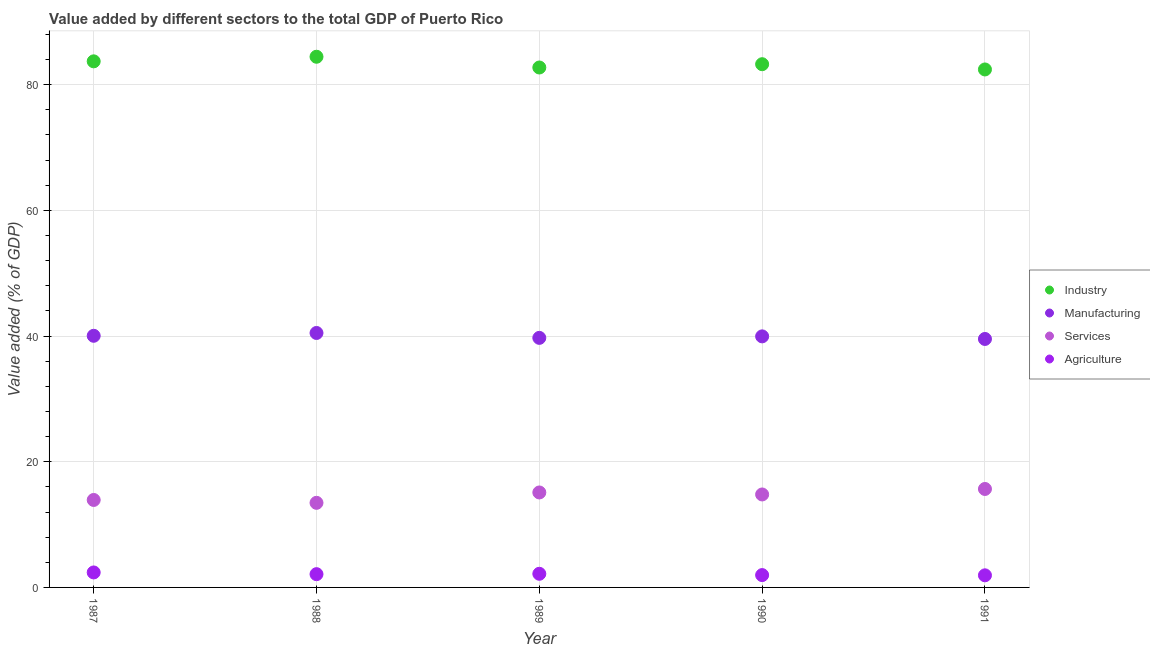Is the number of dotlines equal to the number of legend labels?
Ensure brevity in your answer.  Yes. What is the value added by manufacturing sector in 1989?
Your answer should be very brief. 39.7. Across all years, what is the maximum value added by agricultural sector?
Keep it short and to the point. 2.38. Across all years, what is the minimum value added by agricultural sector?
Your response must be concise. 1.93. In which year was the value added by services sector maximum?
Your answer should be very brief. 1991. In which year was the value added by industrial sector minimum?
Your answer should be very brief. 1991. What is the total value added by manufacturing sector in the graph?
Make the answer very short. 199.7. What is the difference between the value added by agricultural sector in 1988 and that in 1989?
Give a very brief answer. -0.06. What is the difference between the value added by industrial sector in 1987 and the value added by agricultural sector in 1988?
Offer a terse response. 81.59. What is the average value added by services sector per year?
Offer a terse response. 14.59. In the year 1990, what is the difference between the value added by industrial sector and value added by manufacturing sector?
Give a very brief answer. 43.3. In how many years, is the value added by services sector greater than 72 %?
Provide a succinct answer. 0. What is the ratio of the value added by services sector in 1987 to that in 1988?
Make the answer very short. 1.03. Is the difference between the value added by services sector in 1989 and 1991 greater than the difference between the value added by agricultural sector in 1989 and 1991?
Make the answer very short. No. What is the difference between the highest and the second highest value added by industrial sector?
Offer a terse response. 0.73. What is the difference between the highest and the lowest value added by agricultural sector?
Your answer should be very brief. 0.46. In how many years, is the value added by industrial sector greater than the average value added by industrial sector taken over all years?
Give a very brief answer. 2. Is it the case that in every year, the sum of the value added by services sector and value added by industrial sector is greater than the sum of value added by agricultural sector and value added by manufacturing sector?
Make the answer very short. Yes. Is it the case that in every year, the sum of the value added by industrial sector and value added by manufacturing sector is greater than the value added by services sector?
Keep it short and to the point. Yes. Is the value added by manufacturing sector strictly greater than the value added by industrial sector over the years?
Ensure brevity in your answer.  No. Does the graph contain any zero values?
Your response must be concise. No. Does the graph contain grids?
Offer a very short reply. Yes. Where does the legend appear in the graph?
Make the answer very short. Center right. How many legend labels are there?
Your answer should be very brief. 4. What is the title of the graph?
Provide a succinct answer. Value added by different sectors to the total GDP of Puerto Rico. What is the label or title of the X-axis?
Make the answer very short. Year. What is the label or title of the Y-axis?
Ensure brevity in your answer.  Value added (% of GDP). What is the Value added (% of GDP) of Industry in 1987?
Provide a succinct answer. 83.7. What is the Value added (% of GDP) of Manufacturing in 1987?
Offer a very short reply. 40.04. What is the Value added (% of GDP) in Services in 1987?
Give a very brief answer. 13.92. What is the Value added (% of GDP) of Agriculture in 1987?
Your answer should be compact. 2.38. What is the Value added (% of GDP) of Industry in 1988?
Make the answer very short. 84.43. What is the Value added (% of GDP) in Manufacturing in 1988?
Provide a short and direct response. 40.48. What is the Value added (% of GDP) in Services in 1988?
Offer a very short reply. 13.46. What is the Value added (% of GDP) of Agriculture in 1988?
Ensure brevity in your answer.  2.11. What is the Value added (% of GDP) in Industry in 1989?
Your answer should be compact. 82.72. What is the Value added (% of GDP) in Manufacturing in 1989?
Ensure brevity in your answer.  39.7. What is the Value added (% of GDP) of Services in 1989?
Provide a succinct answer. 15.11. What is the Value added (% of GDP) of Agriculture in 1989?
Offer a terse response. 2.17. What is the Value added (% of GDP) of Industry in 1990?
Provide a short and direct response. 83.25. What is the Value added (% of GDP) in Manufacturing in 1990?
Offer a very short reply. 39.94. What is the Value added (% of GDP) in Services in 1990?
Offer a terse response. 14.79. What is the Value added (% of GDP) of Agriculture in 1990?
Make the answer very short. 1.96. What is the Value added (% of GDP) in Industry in 1991?
Your answer should be very brief. 82.41. What is the Value added (% of GDP) of Manufacturing in 1991?
Give a very brief answer. 39.53. What is the Value added (% of GDP) of Services in 1991?
Ensure brevity in your answer.  15.66. What is the Value added (% of GDP) in Agriculture in 1991?
Give a very brief answer. 1.93. Across all years, what is the maximum Value added (% of GDP) in Industry?
Make the answer very short. 84.43. Across all years, what is the maximum Value added (% of GDP) in Manufacturing?
Your response must be concise. 40.48. Across all years, what is the maximum Value added (% of GDP) of Services?
Offer a very short reply. 15.66. Across all years, what is the maximum Value added (% of GDP) of Agriculture?
Offer a very short reply. 2.38. Across all years, what is the minimum Value added (% of GDP) in Industry?
Your response must be concise. 82.41. Across all years, what is the minimum Value added (% of GDP) of Manufacturing?
Offer a very short reply. 39.53. Across all years, what is the minimum Value added (% of GDP) in Services?
Your response must be concise. 13.46. Across all years, what is the minimum Value added (% of GDP) of Agriculture?
Your answer should be very brief. 1.93. What is the total Value added (% of GDP) of Industry in the graph?
Provide a succinct answer. 416.51. What is the total Value added (% of GDP) of Manufacturing in the graph?
Offer a terse response. 199.7. What is the total Value added (% of GDP) in Services in the graph?
Make the answer very short. 72.94. What is the total Value added (% of GDP) in Agriculture in the graph?
Your answer should be compact. 10.55. What is the difference between the Value added (% of GDP) in Industry in 1987 and that in 1988?
Your response must be concise. -0.73. What is the difference between the Value added (% of GDP) of Manufacturing in 1987 and that in 1988?
Your response must be concise. -0.45. What is the difference between the Value added (% of GDP) in Services in 1987 and that in 1988?
Make the answer very short. 0.46. What is the difference between the Value added (% of GDP) in Agriculture in 1987 and that in 1988?
Give a very brief answer. 0.27. What is the difference between the Value added (% of GDP) in Industry in 1987 and that in 1989?
Your answer should be compact. 0.98. What is the difference between the Value added (% of GDP) of Manufacturing in 1987 and that in 1989?
Your answer should be very brief. 0.33. What is the difference between the Value added (% of GDP) in Services in 1987 and that in 1989?
Offer a very short reply. -1.19. What is the difference between the Value added (% of GDP) in Agriculture in 1987 and that in 1989?
Your response must be concise. 0.21. What is the difference between the Value added (% of GDP) of Industry in 1987 and that in 1990?
Your response must be concise. 0.46. What is the difference between the Value added (% of GDP) in Manufacturing in 1987 and that in 1990?
Keep it short and to the point. 0.09. What is the difference between the Value added (% of GDP) of Services in 1987 and that in 1990?
Ensure brevity in your answer.  -0.88. What is the difference between the Value added (% of GDP) in Agriculture in 1987 and that in 1990?
Offer a very short reply. 0.42. What is the difference between the Value added (% of GDP) of Industry in 1987 and that in 1991?
Keep it short and to the point. 1.29. What is the difference between the Value added (% of GDP) of Manufacturing in 1987 and that in 1991?
Offer a very short reply. 0.5. What is the difference between the Value added (% of GDP) of Services in 1987 and that in 1991?
Keep it short and to the point. -1.75. What is the difference between the Value added (% of GDP) in Agriculture in 1987 and that in 1991?
Offer a terse response. 0.46. What is the difference between the Value added (% of GDP) of Industry in 1988 and that in 1989?
Offer a very short reply. 1.71. What is the difference between the Value added (% of GDP) in Manufacturing in 1988 and that in 1989?
Keep it short and to the point. 0.78. What is the difference between the Value added (% of GDP) in Services in 1988 and that in 1989?
Offer a very short reply. -1.65. What is the difference between the Value added (% of GDP) in Agriculture in 1988 and that in 1989?
Provide a short and direct response. -0.06. What is the difference between the Value added (% of GDP) of Industry in 1988 and that in 1990?
Your answer should be compact. 1.19. What is the difference between the Value added (% of GDP) of Manufacturing in 1988 and that in 1990?
Provide a short and direct response. 0.54. What is the difference between the Value added (% of GDP) of Services in 1988 and that in 1990?
Provide a short and direct response. -1.33. What is the difference between the Value added (% of GDP) in Agriculture in 1988 and that in 1990?
Offer a very short reply. 0.15. What is the difference between the Value added (% of GDP) of Industry in 1988 and that in 1991?
Keep it short and to the point. 2.02. What is the difference between the Value added (% of GDP) in Manufacturing in 1988 and that in 1991?
Make the answer very short. 0.95. What is the difference between the Value added (% of GDP) in Services in 1988 and that in 1991?
Your response must be concise. -2.21. What is the difference between the Value added (% of GDP) in Agriculture in 1988 and that in 1991?
Make the answer very short. 0.18. What is the difference between the Value added (% of GDP) of Industry in 1989 and that in 1990?
Give a very brief answer. -0.52. What is the difference between the Value added (% of GDP) in Manufacturing in 1989 and that in 1990?
Your answer should be very brief. -0.24. What is the difference between the Value added (% of GDP) in Services in 1989 and that in 1990?
Your answer should be compact. 0.32. What is the difference between the Value added (% of GDP) in Agriculture in 1989 and that in 1990?
Your answer should be very brief. 0.21. What is the difference between the Value added (% of GDP) of Industry in 1989 and that in 1991?
Provide a succinct answer. 0.31. What is the difference between the Value added (% of GDP) of Manufacturing in 1989 and that in 1991?
Ensure brevity in your answer.  0.17. What is the difference between the Value added (% of GDP) in Services in 1989 and that in 1991?
Your answer should be compact. -0.56. What is the difference between the Value added (% of GDP) of Agriculture in 1989 and that in 1991?
Make the answer very short. 0.24. What is the difference between the Value added (% of GDP) in Industry in 1990 and that in 1991?
Give a very brief answer. 0.84. What is the difference between the Value added (% of GDP) in Manufacturing in 1990 and that in 1991?
Give a very brief answer. 0.41. What is the difference between the Value added (% of GDP) of Services in 1990 and that in 1991?
Offer a very short reply. -0.87. What is the difference between the Value added (% of GDP) of Agriculture in 1990 and that in 1991?
Ensure brevity in your answer.  0.04. What is the difference between the Value added (% of GDP) in Industry in 1987 and the Value added (% of GDP) in Manufacturing in 1988?
Keep it short and to the point. 43.22. What is the difference between the Value added (% of GDP) of Industry in 1987 and the Value added (% of GDP) of Services in 1988?
Keep it short and to the point. 70.24. What is the difference between the Value added (% of GDP) of Industry in 1987 and the Value added (% of GDP) of Agriculture in 1988?
Provide a succinct answer. 81.59. What is the difference between the Value added (% of GDP) in Manufacturing in 1987 and the Value added (% of GDP) in Services in 1988?
Offer a terse response. 26.58. What is the difference between the Value added (% of GDP) of Manufacturing in 1987 and the Value added (% of GDP) of Agriculture in 1988?
Provide a succinct answer. 37.92. What is the difference between the Value added (% of GDP) of Services in 1987 and the Value added (% of GDP) of Agriculture in 1988?
Ensure brevity in your answer.  11.81. What is the difference between the Value added (% of GDP) of Industry in 1987 and the Value added (% of GDP) of Manufacturing in 1989?
Your answer should be compact. 44. What is the difference between the Value added (% of GDP) of Industry in 1987 and the Value added (% of GDP) of Services in 1989?
Give a very brief answer. 68.59. What is the difference between the Value added (% of GDP) in Industry in 1987 and the Value added (% of GDP) in Agriculture in 1989?
Provide a short and direct response. 81.53. What is the difference between the Value added (% of GDP) of Manufacturing in 1987 and the Value added (% of GDP) of Services in 1989?
Ensure brevity in your answer.  24.93. What is the difference between the Value added (% of GDP) in Manufacturing in 1987 and the Value added (% of GDP) in Agriculture in 1989?
Ensure brevity in your answer.  37.87. What is the difference between the Value added (% of GDP) in Services in 1987 and the Value added (% of GDP) in Agriculture in 1989?
Provide a succinct answer. 11.75. What is the difference between the Value added (% of GDP) of Industry in 1987 and the Value added (% of GDP) of Manufacturing in 1990?
Your response must be concise. 43.76. What is the difference between the Value added (% of GDP) of Industry in 1987 and the Value added (% of GDP) of Services in 1990?
Your answer should be very brief. 68.91. What is the difference between the Value added (% of GDP) in Industry in 1987 and the Value added (% of GDP) in Agriculture in 1990?
Your response must be concise. 81.74. What is the difference between the Value added (% of GDP) of Manufacturing in 1987 and the Value added (% of GDP) of Services in 1990?
Ensure brevity in your answer.  25.24. What is the difference between the Value added (% of GDP) in Manufacturing in 1987 and the Value added (% of GDP) in Agriculture in 1990?
Give a very brief answer. 38.07. What is the difference between the Value added (% of GDP) in Services in 1987 and the Value added (% of GDP) in Agriculture in 1990?
Provide a short and direct response. 11.95. What is the difference between the Value added (% of GDP) of Industry in 1987 and the Value added (% of GDP) of Manufacturing in 1991?
Ensure brevity in your answer.  44.17. What is the difference between the Value added (% of GDP) in Industry in 1987 and the Value added (% of GDP) in Services in 1991?
Provide a succinct answer. 68.04. What is the difference between the Value added (% of GDP) of Industry in 1987 and the Value added (% of GDP) of Agriculture in 1991?
Give a very brief answer. 81.77. What is the difference between the Value added (% of GDP) of Manufacturing in 1987 and the Value added (% of GDP) of Services in 1991?
Provide a succinct answer. 24.37. What is the difference between the Value added (% of GDP) of Manufacturing in 1987 and the Value added (% of GDP) of Agriculture in 1991?
Provide a succinct answer. 38.11. What is the difference between the Value added (% of GDP) in Services in 1987 and the Value added (% of GDP) in Agriculture in 1991?
Offer a very short reply. 11.99. What is the difference between the Value added (% of GDP) in Industry in 1988 and the Value added (% of GDP) in Manufacturing in 1989?
Your response must be concise. 44.73. What is the difference between the Value added (% of GDP) of Industry in 1988 and the Value added (% of GDP) of Services in 1989?
Your answer should be compact. 69.32. What is the difference between the Value added (% of GDP) of Industry in 1988 and the Value added (% of GDP) of Agriculture in 1989?
Offer a terse response. 82.26. What is the difference between the Value added (% of GDP) of Manufacturing in 1988 and the Value added (% of GDP) of Services in 1989?
Make the answer very short. 25.37. What is the difference between the Value added (% of GDP) of Manufacturing in 1988 and the Value added (% of GDP) of Agriculture in 1989?
Give a very brief answer. 38.31. What is the difference between the Value added (% of GDP) in Services in 1988 and the Value added (% of GDP) in Agriculture in 1989?
Your answer should be compact. 11.29. What is the difference between the Value added (% of GDP) of Industry in 1988 and the Value added (% of GDP) of Manufacturing in 1990?
Ensure brevity in your answer.  44.49. What is the difference between the Value added (% of GDP) in Industry in 1988 and the Value added (% of GDP) in Services in 1990?
Offer a terse response. 69.64. What is the difference between the Value added (% of GDP) of Industry in 1988 and the Value added (% of GDP) of Agriculture in 1990?
Ensure brevity in your answer.  82.47. What is the difference between the Value added (% of GDP) in Manufacturing in 1988 and the Value added (% of GDP) in Services in 1990?
Make the answer very short. 25.69. What is the difference between the Value added (% of GDP) of Manufacturing in 1988 and the Value added (% of GDP) of Agriculture in 1990?
Give a very brief answer. 38.52. What is the difference between the Value added (% of GDP) of Services in 1988 and the Value added (% of GDP) of Agriculture in 1990?
Ensure brevity in your answer.  11.5. What is the difference between the Value added (% of GDP) in Industry in 1988 and the Value added (% of GDP) in Manufacturing in 1991?
Provide a short and direct response. 44.9. What is the difference between the Value added (% of GDP) of Industry in 1988 and the Value added (% of GDP) of Services in 1991?
Offer a terse response. 68.77. What is the difference between the Value added (% of GDP) of Industry in 1988 and the Value added (% of GDP) of Agriculture in 1991?
Make the answer very short. 82.5. What is the difference between the Value added (% of GDP) in Manufacturing in 1988 and the Value added (% of GDP) in Services in 1991?
Offer a terse response. 24.82. What is the difference between the Value added (% of GDP) of Manufacturing in 1988 and the Value added (% of GDP) of Agriculture in 1991?
Offer a terse response. 38.56. What is the difference between the Value added (% of GDP) of Services in 1988 and the Value added (% of GDP) of Agriculture in 1991?
Offer a very short reply. 11.53. What is the difference between the Value added (% of GDP) in Industry in 1989 and the Value added (% of GDP) in Manufacturing in 1990?
Provide a succinct answer. 42.78. What is the difference between the Value added (% of GDP) in Industry in 1989 and the Value added (% of GDP) in Services in 1990?
Keep it short and to the point. 67.93. What is the difference between the Value added (% of GDP) in Industry in 1989 and the Value added (% of GDP) in Agriculture in 1990?
Give a very brief answer. 80.76. What is the difference between the Value added (% of GDP) in Manufacturing in 1989 and the Value added (% of GDP) in Services in 1990?
Your answer should be very brief. 24.91. What is the difference between the Value added (% of GDP) in Manufacturing in 1989 and the Value added (% of GDP) in Agriculture in 1990?
Ensure brevity in your answer.  37.74. What is the difference between the Value added (% of GDP) of Services in 1989 and the Value added (% of GDP) of Agriculture in 1990?
Your answer should be compact. 13.15. What is the difference between the Value added (% of GDP) of Industry in 1989 and the Value added (% of GDP) of Manufacturing in 1991?
Your answer should be compact. 43.19. What is the difference between the Value added (% of GDP) of Industry in 1989 and the Value added (% of GDP) of Services in 1991?
Offer a terse response. 67.06. What is the difference between the Value added (% of GDP) in Industry in 1989 and the Value added (% of GDP) in Agriculture in 1991?
Your response must be concise. 80.8. What is the difference between the Value added (% of GDP) in Manufacturing in 1989 and the Value added (% of GDP) in Services in 1991?
Keep it short and to the point. 24.04. What is the difference between the Value added (% of GDP) of Manufacturing in 1989 and the Value added (% of GDP) of Agriculture in 1991?
Make the answer very short. 37.78. What is the difference between the Value added (% of GDP) of Services in 1989 and the Value added (% of GDP) of Agriculture in 1991?
Your response must be concise. 13.18. What is the difference between the Value added (% of GDP) of Industry in 1990 and the Value added (% of GDP) of Manufacturing in 1991?
Provide a short and direct response. 43.71. What is the difference between the Value added (% of GDP) in Industry in 1990 and the Value added (% of GDP) in Services in 1991?
Provide a succinct answer. 67.58. What is the difference between the Value added (% of GDP) of Industry in 1990 and the Value added (% of GDP) of Agriculture in 1991?
Offer a terse response. 81.32. What is the difference between the Value added (% of GDP) of Manufacturing in 1990 and the Value added (% of GDP) of Services in 1991?
Ensure brevity in your answer.  24.28. What is the difference between the Value added (% of GDP) of Manufacturing in 1990 and the Value added (% of GDP) of Agriculture in 1991?
Your answer should be compact. 38.02. What is the difference between the Value added (% of GDP) of Services in 1990 and the Value added (% of GDP) of Agriculture in 1991?
Make the answer very short. 12.87. What is the average Value added (% of GDP) of Industry per year?
Provide a short and direct response. 83.3. What is the average Value added (% of GDP) in Manufacturing per year?
Make the answer very short. 39.94. What is the average Value added (% of GDP) of Services per year?
Give a very brief answer. 14.59. What is the average Value added (% of GDP) in Agriculture per year?
Your answer should be very brief. 2.11. In the year 1987, what is the difference between the Value added (% of GDP) of Industry and Value added (% of GDP) of Manufacturing?
Make the answer very short. 43.66. In the year 1987, what is the difference between the Value added (% of GDP) in Industry and Value added (% of GDP) in Services?
Your answer should be very brief. 69.78. In the year 1987, what is the difference between the Value added (% of GDP) in Industry and Value added (% of GDP) in Agriculture?
Give a very brief answer. 81.32. In the year 1987, what is the difference between the Value added (% of GDP) of Manufacturing and Value added (% of GDP) of Services?
Your response must be concise. 26.12. In the year 1987, what is the difference between the Value added (% of GDP) in Manufacturing and Value added (% of GDP) in Agriculture?
Offer a very short reply. 37.65. In the year 1987, what is the difference between the Value added (% of GDP) of Services and Value added (% of GDP) of Agriculture?
Provide a succinct answer. 11.53. In the year 1988, what is the difference between the Value added (% of GDP) in Industry and Value added (% of GDP) in Manufacturing?
Give a very brief answer. 43.95. In the year 1988, what is the difference between the Value added (% of GDP) in Industry and Value added (% of GDP) in Services?
Provide a short and direct response. 70.97. In the year 1988, what is the difference between the Value added (% of GDP) of Industry and Value added (% of GDP) of Agriculture?
Ensure brevity in your answer.  82.32. In the year 1988, what is the difference between the Value added (% of GDP) of Manufacturing and Value added (% of GDP) of Services?
Your response must be concise. 27.02. In the year 1988, what is the difference between the Value added (% of GDP) of Manufacturing and Value added (% of GDP) of Agriculture?
Provide a short and direct response. 38.37. In the year 1988, what is the difference between the Value added (% of GDP) in Services and Value added (% of GDP) in Agriculture?
Offer a very short reply. 11.35. In the year 1989, what is the difference between the Value added (% of GDP) in Industry and Value added (% of GDP) in Manufacturing?
Your response must be concise. 43.02. In the year 1989, what is the difference between the Value added (% of GDP) in Industry and Value added (% of GDP) in Services?
Make the answer very short. 67.61. In the year 1989, what is the difference between the Value added (% of GDP) in Industry and Value added (% of GDP) in Agriculture?
Give a very brief answer. 80.55. In the year 1989, what is the difference between the Value added (% of GDP) of Manufacturing and Value added (% of GDP) of Services?
Ensure brevity in your answer.  24.59. In the year 1989, what is the difference between the Value added (% of GDP) of Manufacturing and Value added (% of GDP) of Agriculture?
Provide a short and direct response. 37.53. In the year 1989, what is the difference between the Value added (% of GDP) in Services and Value added (% of GDP) in Agriculture?
Make the answer very short. 12.94. In the year 1990, what is the difference between the Value added (% of GDP) in Industry and Value added (% of GDP) in Manufacturing?
Make the answer very short. 43.3. In the year 1990, what is the difference between the Value added (% of GDP) of Industry and Value added (% of GDP) of Services?
Provide a short and direct response. 68.45. In the year 1990, what is the difference between the Value added (% of GDP) of Industry and Value added (% of GDP) of Agriculture?
Your response must be concise. 81.28. In the year 1990, what is the difference between the Value added (% of GDP) in Manufacturing and Value added (% of GDP) in Services?
Your answer should be very brief. 25.15. In the year 1990, what is the difference between the Value added (% of GDP) of Manufacturing and Value added (% of GDP) of Agriculture?
Give a very brief answer. 37.98. In the year 1990, what is the difference between the Value added (% of GDP) in Services and Value added (% of GDP) in Agriculture?
Provide a succinct answer. 12.83. In the year 1991, what is the difference between the Value added (% of GDP) of Industry and Value added (% of GDP) of Manufacturing?
Offer a very short reply. 42.88. In the year 1991, what is the difference between the Value added (% of GDP) of Industry and Value added (% of GDP) of Services?
Your answer should be compact. 66.75. In the year 1991, what is the difference between the Value added (% of GDP) of Industry and Value added (% of GDP) of Agriculture?
Your answer should be compact. 80.48. In the year 1991, what is the difference between the Value added (% of GDP) of Manufacturing and Value added (% of GDP) of Services?
Offer a very short reply. 23.87. In the year 1991, what is the difference between the Value added (% of GDP) of Manufacturing and Value added (% of GDP) of Agriculture?
Your answer should be compact. 37.61. In the year 1991, what is the difference between the Value added (% of GDP) of Services and Value added (% of GDP) of Agriculture?
Offer a very short reply. 13.74. What is the ratio of the Value added (% of GDP) in Industry in 1987 to that in 1988?
Ensure brevity in your answer.  0.99. What is the ratio of the Value added (% of GDP) of Manufacturing in 1987 to that in 1988?
Provide a succinct answer. 0.99. What is the ratio of the Value added (% of GDP) of Services in 1987 to that in 1988?
Provide a succinct answer. 1.03. What is the ratio of the Value added (% of GDP) of Agriculture in 1987 to that in 1988?
Your response must be concise. 1.13. What is the ratio of the Value added (% of GDP) of Industry in 1987 to that in 1989?
Offer a very short reply. 1.01. What is the ratio of the Value added (% of GDP) in Manufacturing in 1987 to that in 1989?
Ensure brevity in your answer.  1.01. What is the ratio of the Value added (% of GDP) in Services in 1987 to that in 1989?
Your answer should be compact. 0.92. What is the ratio of the Value added (% of GDP) of Agriculture in 1987 to that in 1989?
Offer a very short reply. 1.1. What is the ratio of the Value added (% of GDP) in Manufacturing in 1987 to that in 1990?
Offer a very short reply. 1. What is the ratio of the Value added (% of GDP) in Services in 1987 to that in 1990?
Offer a very short reply. 0.94. What is the ratio of the Value added (% of GDP) in Agriculture in 1987 to that in 1990?
Keep it short and to the point. 1.21. What is the ratio of the Value added (% of GDP) of Industry in 1987 to that in 1991?
Keep it short and to the point. 1.02. What is the ratio of the Value added (% of GDP) in Manufacturing in 1987 to that in 1991?
Provide a succinct answer. 1.01. What is the ratio of the Value added (% of GDP) of Services in 1987 to that in 1991?
Your response must be concise. 0.89. What is the ratio of the Value added (% of GDP) in Agriculture in 1987 to that in 1991?
Ensure brevity in your answer.  1.24. What is the ratio of the Value added (% of GDP) of Industry in 1988 to that in 1989?
Ensure brevity in your answer.  1.02. What is the ratio of the Value added (% of GDP) of Manufacturing in 1988 to that in 1989?
Provide a short and direct response. 1.02. What is the ratio of the Value added (% of GDP) in Services in 1988 to that in 1989?
Provide a short and direct response. 0.89. What is the ratio of the Value added (% of GDP) in Agriculture in 1988 to that in 1989?
Your answer should be very brief. 0.97. What is the ratio of the Value added (% of GDP) of Industry in 1988 to that in 1990?
Make the answer very short. 1.01. What is the ratio of the Value added (% of GDP) in Manufacturing in 1988 to that in 1990?
Offer a very short reply. 1.01. What is the ratio of the Value added (% of GDP) of Services in 1988 to that in 1990?
Provide a short and direct response. 0.91. What is the ratio of the Value added (% of GDP) of Agriculture in 1988 to that in 1990?
Your response must be concise. 1.07. What is the ratio of the Value added (% of GDP) of Industry in 1988 to that in 1991?
Provide a short and direct response. 1.02. What is the ratio of the Value added (% of GDP) of Manufacturing in 1988 to that in 1991?
Your answer should be compact. 1.02. What is the ratio of the Value added (% of GDP) of Services in 1988 to that in 1991?
Ensure brevity in your answer.  0.86. What is the ratio of the Value added (% of GDP) in Agriculture in 1988 to that in 1991?
Give a very brief answer. 1.1. What is the ratio of the Value added (% of GDP) in Services in 1989 to that in 1990?
Offer a terse response. 1.02. What is the ratio of the Value added (% of GDP) of Agriculture in 1989 to that in 1990?
Your response must be concise. 1.11. What is the ratio of the Value added (% of GDP) of Services in 1989 to that in 1991?
Your answer should be compact. 0.96. What is the ratio of the Value added (% of GDP) in Agriculture in 1989 to that in 1991?
Keep it short and to the point. 1.13. What is the ratio of the Value added (% of GDP) in Industry in 1990 to that in 1991?
Your answer should be very brief. 1.01. What is the ratio of the Value added (% of GDP) of Manufacturing in 1990 to that in 1991?
Your answer should be very brief. 1.01. What is the ratio of the Value added (% of GDP) in Services in 1990 to that in 1991?
Offer a very short reply. 0.94. What is the ratio of the Value added (% of GDP) in Agriculture in 1990 to that in 1991?
Offer a terse response. 1.02. What is the difference between the highest and the second highest Value added (% of GDP) in Industry?
Provide a succinct answer. 0.73. What is the difference between the highest and the second highest Value added (% of GDP) in Manufacturing?
Ensure brevity in your answer.  0.45. What is the difference between the highest and the second highest Value added (% of GDP) in Services?
Offer a very short reply. 0.56. What is the difference between the highest and the second highest Value added (% of GDP) of Agriculture?
Offer a terse response. 0.21. What is the difference between the highest and the lowest Value added (% of GDP) of Industry?
Offer a terse response. 2.02. What is the difference between the highest and the lowest Value added (% of GDP) in Manufacturing?
Your response must be concise. 0.95. What is the difference between the highest and the lowest Value added (% of GDP) in Services?
Provide a succinct answer. 2.21. What is the difference between the highest and the lowest Value added (% of GDP) in Agriculture?
Your answer should be very brief. 0.46. 